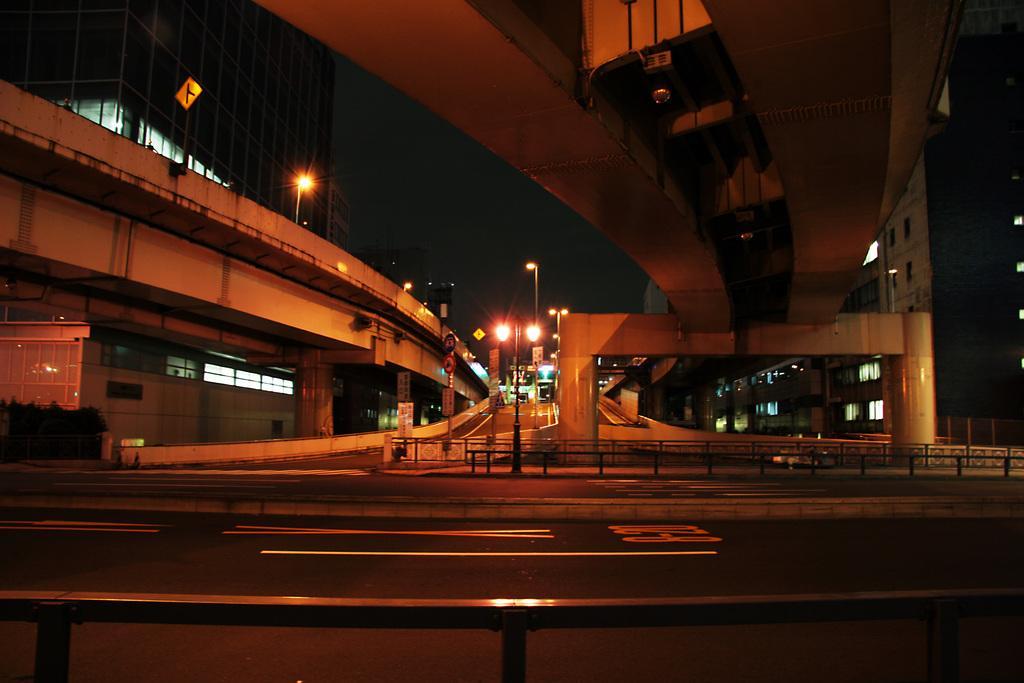Could you give a brief overview of what you see in this image? In this image we can see road, flyover, building, street lights, pillars and plants. 